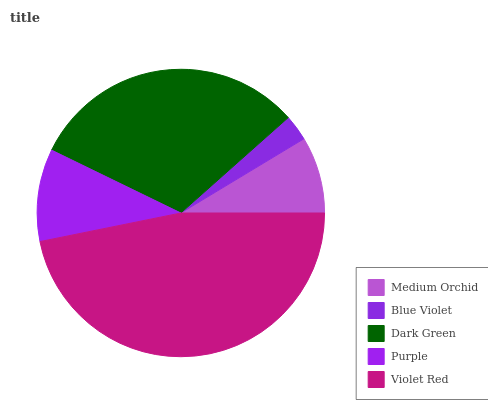Is Blue Violet the minimum?
Answer yes or no. Yes. Is Violet Red the maximum?
Answer yes or no. Yes. Is Dark Green the minimum?
Answer yes or no. No. Is Dark Green the maximum?
Answer yes or no. No. Is Dark Green greater than Blue Violet?
Answer yes or no. Yes. Is Blue Violet less than Dark Green?
Answer yes or no. Yes. Is Blue Violet greater than Dark Green?
Answer yes or no. No. Is Dark Green less than Blue Violet?
Answer yes or no. No. Is Purple the high median?
Answer yes or no. Yes. Is Purple the low median?
Answer yes or no. Yes. Is Violet Red the high median?
Answer yes or no. No. Is Blue Violet the low median?
Answer yes or no. No. 